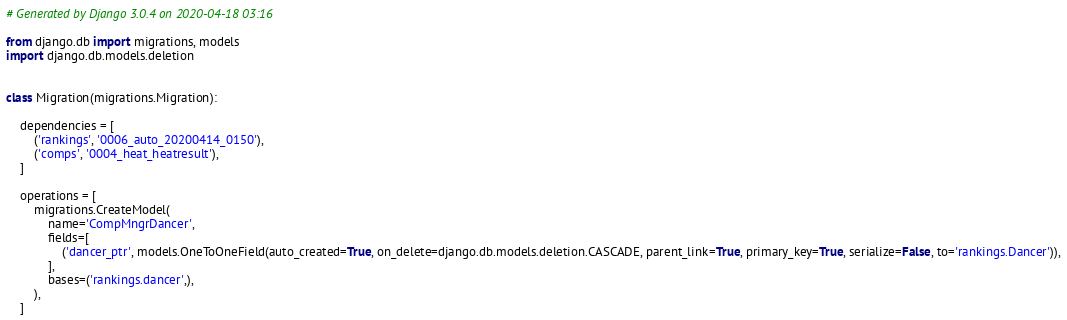Convert code to text. <code><loc_0><loc_0><loc_500><loc_500><_Python_># Generated by Django 3.0.4 on 2020-04-18 03:16

from django.db import migrations, models
import django.db.models.deletion


class Migration(migrations.Migration):

    dependencies = [
        ('rankings', '0006_auto_20200414_0150'),
        ('comps', '0004_heat_heatresult'),
    ]

    operations = [
        migrations.CreateModel(
            name='CompMngrDancer',
            fields=[
                ('dancer_ptr', models.OneToOneField(auto_created=True, on_delete=django.db.models.deletion.CASCADE, parent_link=True, primary_key=True, serialize=False, to='rankings.Dancer')),
            ],
            bases=('rankings.dancer',),
        ),
    ]
</code> 